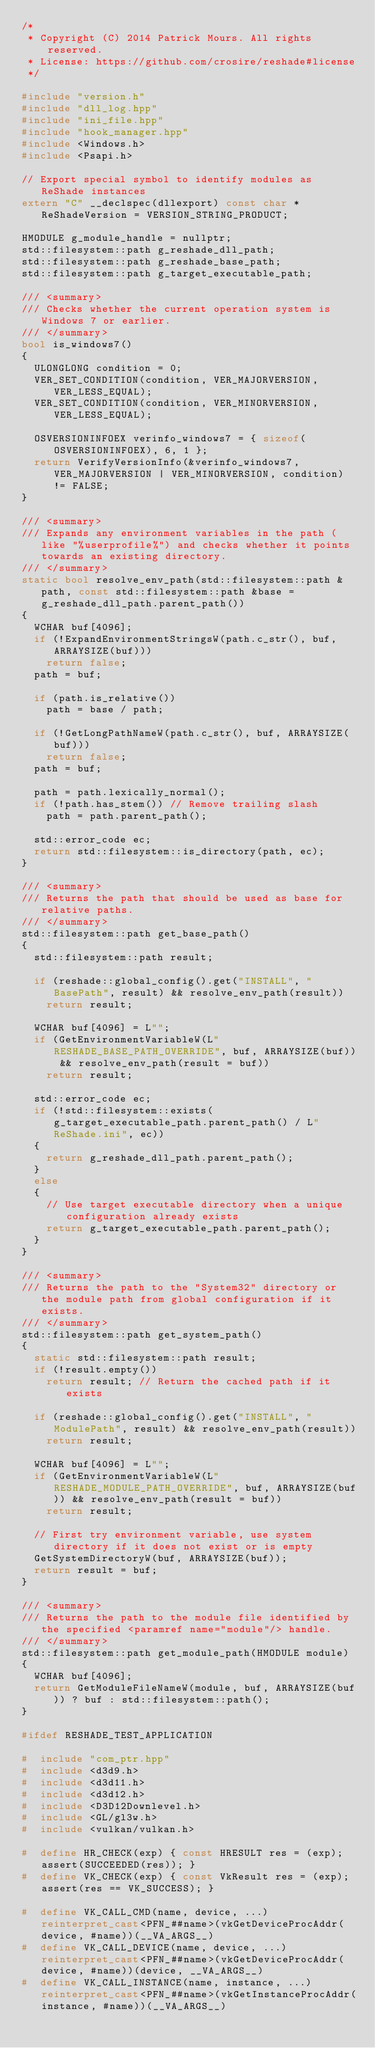Convert code to text. <code><loc_0><loc_0><loc_500><loc_500><_C++_>/*
 * Copyright (C) 2014 Patrick Mours. All rights reserved.
 * License: https://github.com/crosire/reshade#license
 */

#include "version.h"
#include "dll_log.hpp"
#include "ini_file.hpp"
#include "hook_manager.hpp"
#include <Windows.h>
#include <Psapi.h>

// Export special symbol to identify modules as ReShade instances
extern "C" __declspec(dllexport) const char *ReShadeVersion = VERSION_STRING_PRODUCT;

HMODULE g_module_handle = nullptr;
std::filesystem::path g_reshade_dll_path;
std::filesystem::path g_reshade_base_path;
std::filesystem::path g_target_executable_path;

/// <summary>
/// Checks whether the current operation system is Windows 7 or earlier.
/// </summary>
bool is_windows7()
{
	ULONGLONG condition = 0;
	VER_SET_CONDITION(condition, VER_MAJORVERSION, VER_LESS_EQUAL);
	VER_SET_CONDITION(condition, VER_MINORVERSION, VER_LESS_EQUAL);

	OSVERSIONINFOEX verinfo_windows7 = { sizeof(OSVERSIONINFOEX), 6, 1 };
	return VerifyVersionInfo(&verinfo_windows7, VER_MAJORVERSION | VER_MINORVERSION, condition) != FALSE;
}

/// <summary>
/// Expands any environment variables in the path (like "%userprofile%") and checks whether it points towards an existing directory.
/// </summary>
static bool resolve_env_path(std::filesystem::path &path, const std::filesystem::path &base = g_reshade_dll_path.parent_path())
{
	WCHAR buf[4096];
	if (!ExpandEnvironmentStringsW(path.c_str(), buf, ARRAYSIZE(buf)))
		return false;
	path = buf;

	if (path.is_relative())
		path = base / path;

	if (!GetLongPathNameW(path.c_str(), buf, ARRAYSIZE(buf)))
		return false;
	path = buf;

	path = path.lexically_normal();
	if (!path.has_stem()) // Remove trailing slash
		path = path.parent_path();

	std::error_code ec;
	return std::filesystem::is_directory(path, ec);
}

/// <summary>
/// Returns the path that should be used as base for relative paths.
/// </summary>
std::filesystem::path get_base_path()
{
	std::filesystem::path result;

	if (reshade::global_config().get("INSTALL", "BasePath", result) && resolve_env_path(result))
		return result;

	WCHAR buf[4096] = L"";
	if (GetEnvironmentVariableW(L"RESHADE_BASE_PATH_OVERRIDE", buf, ARRAYSIZE(buf)) && resolve_env_path(result = buf))
		return result;

	std::error_code ec;
	if (!std::filesystem::exists(g_target_executable_path.parent_path() / L"ReShade.ini", ec))
	{
		return g_reshade_dll_path.parent_path();
	}
	else
	{
		// Use target executable directory when a unique configuration already exists
		return g_target_executable_path.parent_path();
	}
}

/// <summary>
/// Returns the path to the "System32" directory or the module path from global configuration if it exists.
/// </summary>
std::filesystem::path get_system_path()
{
	static std::filesystem::path result;
	if (!result.empty())
		return result; // Return the cached path if it exists

	if (reshade::global_config().get("INSTALL", "ModulePath", result) && resolve_env_path(result))
		return result;

	WCHAR buf[4096] = L"";
	if (GetEnvironmentVariableW(L"RESHADE_MODULE_PATH_OVERRIDE", buf, ARRAYSIZE(buf)) && resolve_env_path(result = buf))
		return result;

	// First try environment variable, use system directory if it does not exist or is empty
	GetSystemDirectoryW(buf, ARRAYSIZE(buf));
	return result = buf;
}

/// <summary>
/// Returns the path to the module file identified by the specified <paramref name="module"/> handle.
/// </summary>
std::filesystem::path get_module_path(HMODULE module)
{
	WCHAR buf[4096];
	return GetModuleFileNameW(module, buf, ARRAYSIZE(buf)) ? buf : std::filesystem::path();
}

#ifdef RESHADE_TEST_APPLICATION

#  include "com_ptr.hpp"
#  include <d3d9.h>
#  include <d3d11.h>
#  include <d3d12.h>
#  include <D3D12Downlevel.h>
#  include <GL/gl3w.h>
#  include <vulkan/vulkan.h>

#  define HR_CHECK(exp) { const HRESULT res = (exp); assert(SUCCEEDED(res)); }
#  define VK_CHECK(exp) { const VkResult res = (exp); assert(res == VK_SUCCESS); }

#  define VK_CALL_CMD(name, device, ...) reinterpret_cast<PFN_##name>(vkGetDeviceProcAddr(device, #name))(__VA_ARGS__)
#  define VK_CALL_DEVICE(name, device, ...) reinterpret_cast<PFN_##name>(vkGetDeviceProcAddr(device, #name))(device, __VA_ARGS__)
#  define VK_CALL_INSTANCE(name, instance, ...) reinterpret_cast<PFN_##name>(vkGetInstanceProcAddr(instance, #name))(__VA_ARGS__)
</code> 